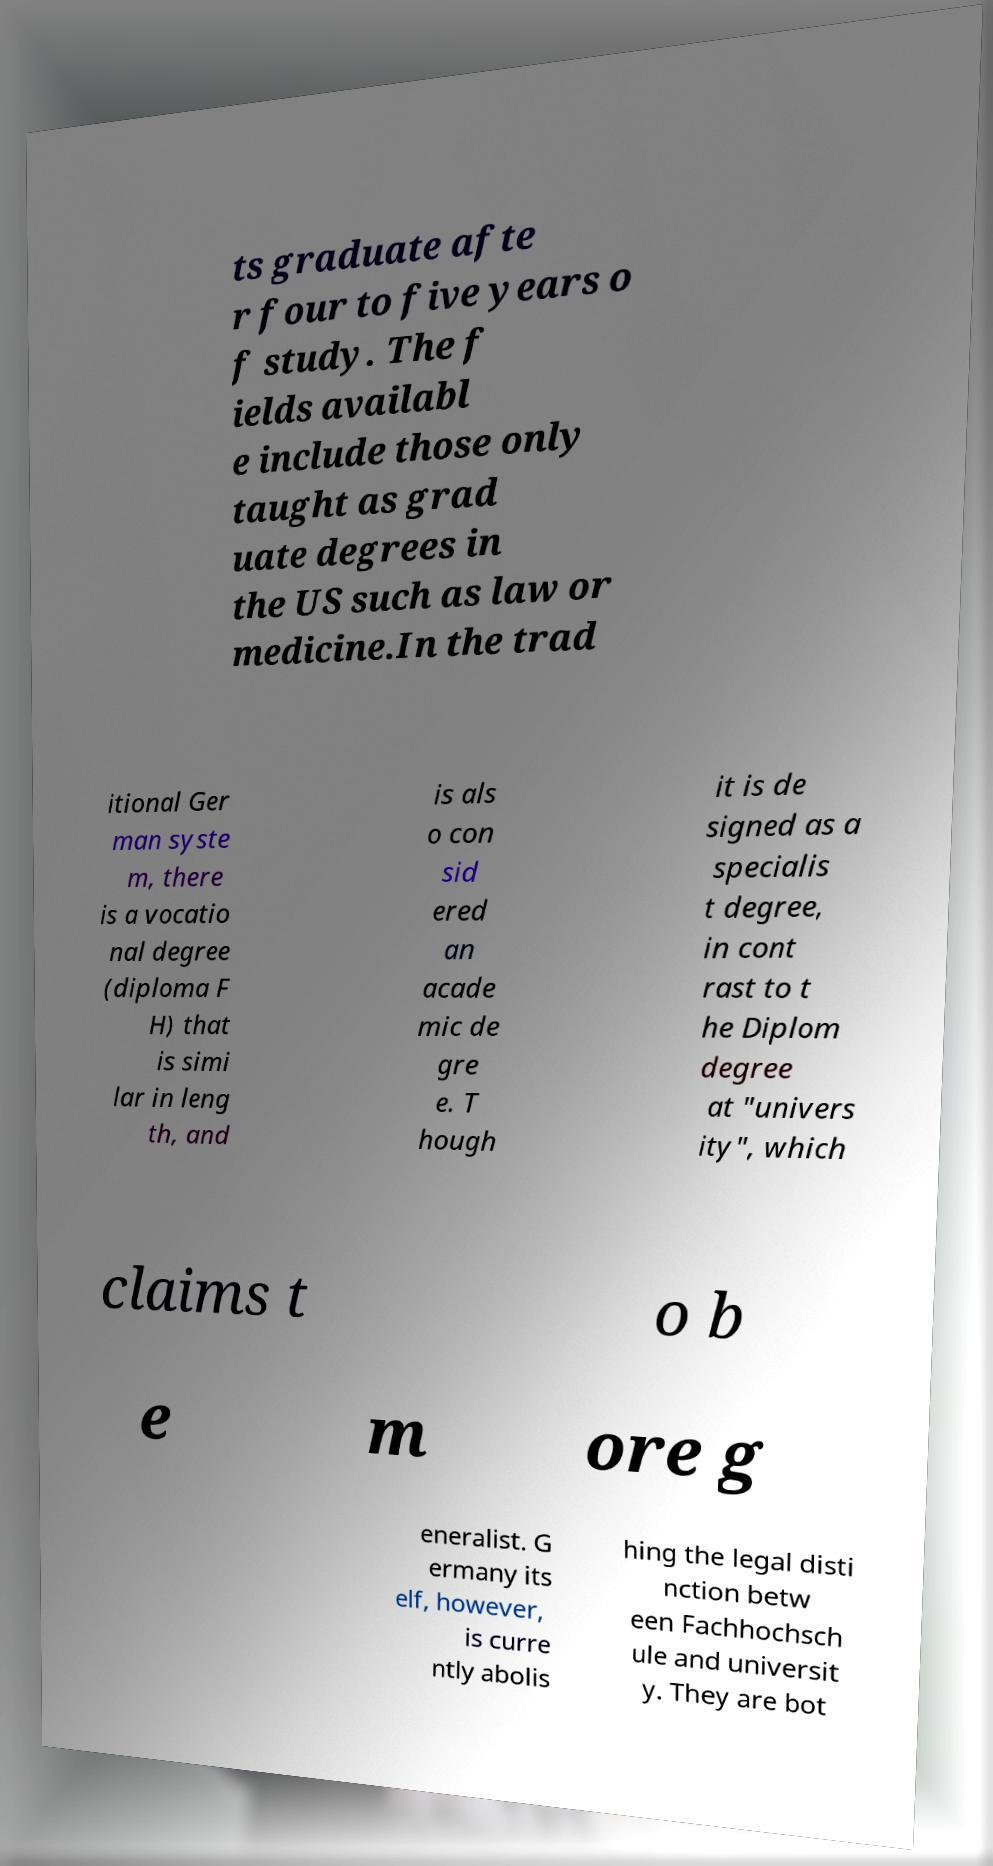Could you assist in decoding the text presented in this image and type it out clearly? ts graduate afte r four to five years o f study. The f ields availabl e include those only taught as grad uate degrees in the US such as law or medicine.In the trad itional Ger man syste m, there is a vocatio nal degree (diploma F H) that is simi lar in leng th, and is als o con sid ered an acade mic de gre e. T hough it is de signed as a specialis t degree, in cont rast to t he Diplom degree at "univers ity", which claims t o b e m ore g eneralist. G ermany its elf, however, is curre ntly abolis hing the legal disti nction betw een Fachhochsch ule and universit y. They are bot 